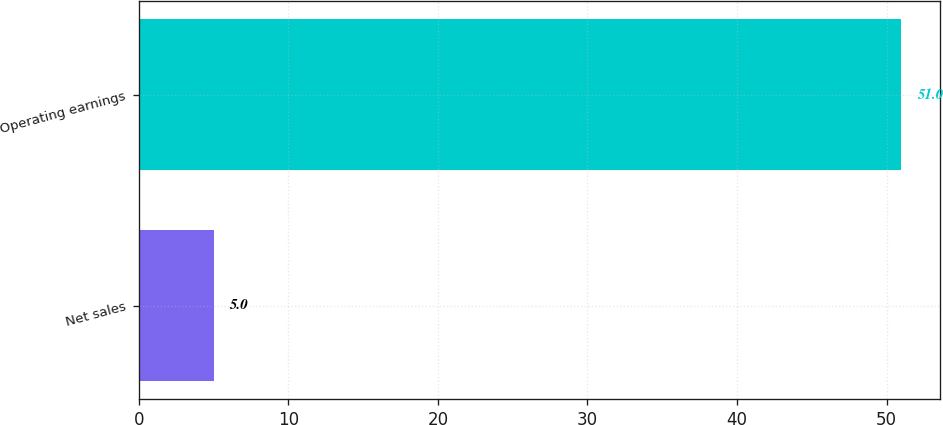Convert chart. <chart><loc_0><loc_0><loc_500><loc_500><bar_chart><fcel>Net sales<fcel>Operating earnings<nl><fcel>5<fcel>51<nl></chart> 